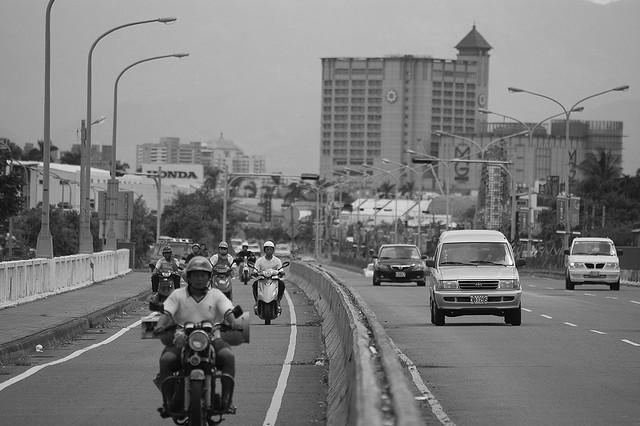What time of day is this?
Give a very brief answer. Afternoon. What is on the sides of the motorbike?
Give a very brief answer. Legs. What kind of shoes is this cyclist wearing?
Write a very short answer. Boots. What type of vehicle is on the left?
Short answer required. Motorcycle. What is in the main roadway?
Quick response, please. Cars. Where is this taken place?
Concise answer only. City. Are the cars on the left in traffic or parked?
Quick response, please. In traffic. How many streetlights do you see?
Keep it brief. 20. Is it a coincidence that the vehicles depicted on the left are all the same type?
Quick response, please. No. 